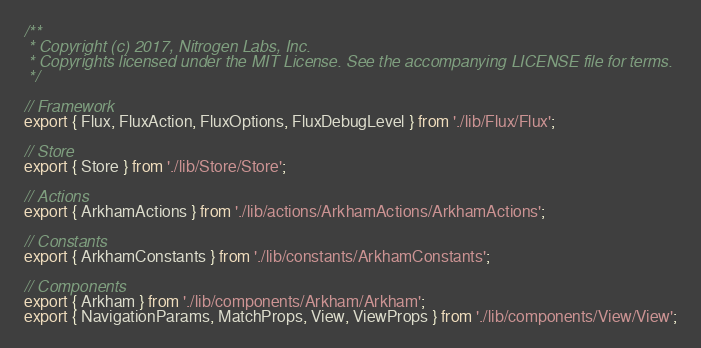<code> <loc_0><loc_0><loc_500><loc_500><_JavaScript_>/**
 * Copyright (c) 2017, Nitrogen Labs, Inc.
 * Copyrights licensed under the MIT License. See the accompanying LICENSE file for terms.
 */

// Framework
export { Flux, FluxAction, FluxOptions, FluxDebugLevel } from './lib/Flux/Flux';

// Store
export { Store } from './lib/Store/Store';

// Actions
export { ArkhamActions } from './lib/actions/ArkhamActions/ArkhamActions';

// Constants
export { ArkhamConstants } from './lib/constants/ArkhamConstants';

// Components
export { Arkham } from './lib/components/Arkham/Arkham';
export { NavigationParams, MatchProps, View, ViewProps } from './lib/components/View/View';</code> 